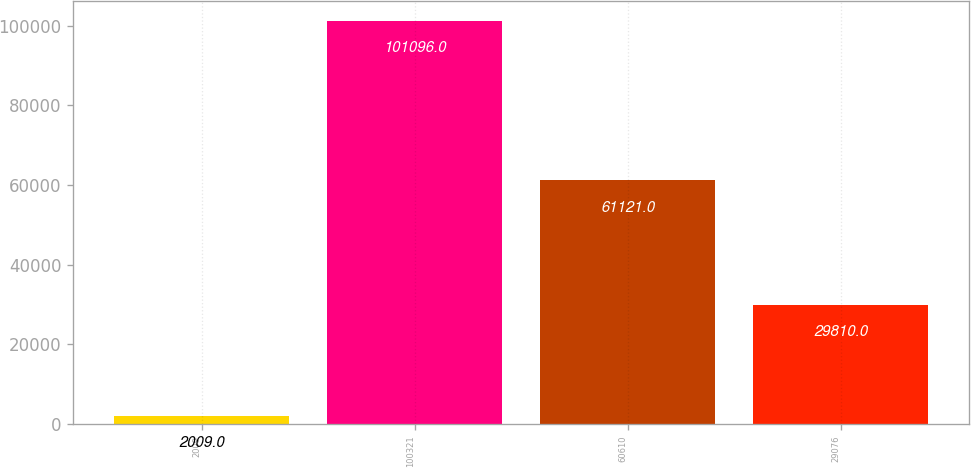Convert chart. <chart><loc_0><loc_0><loc_500><loc_500><bar_chart><fcel>2009<fcel>100321<fcel>60610<fcel>29076<nl><fcel>2009<fcel>101096<fcel>61121<fcel>29810<nl></chart> 